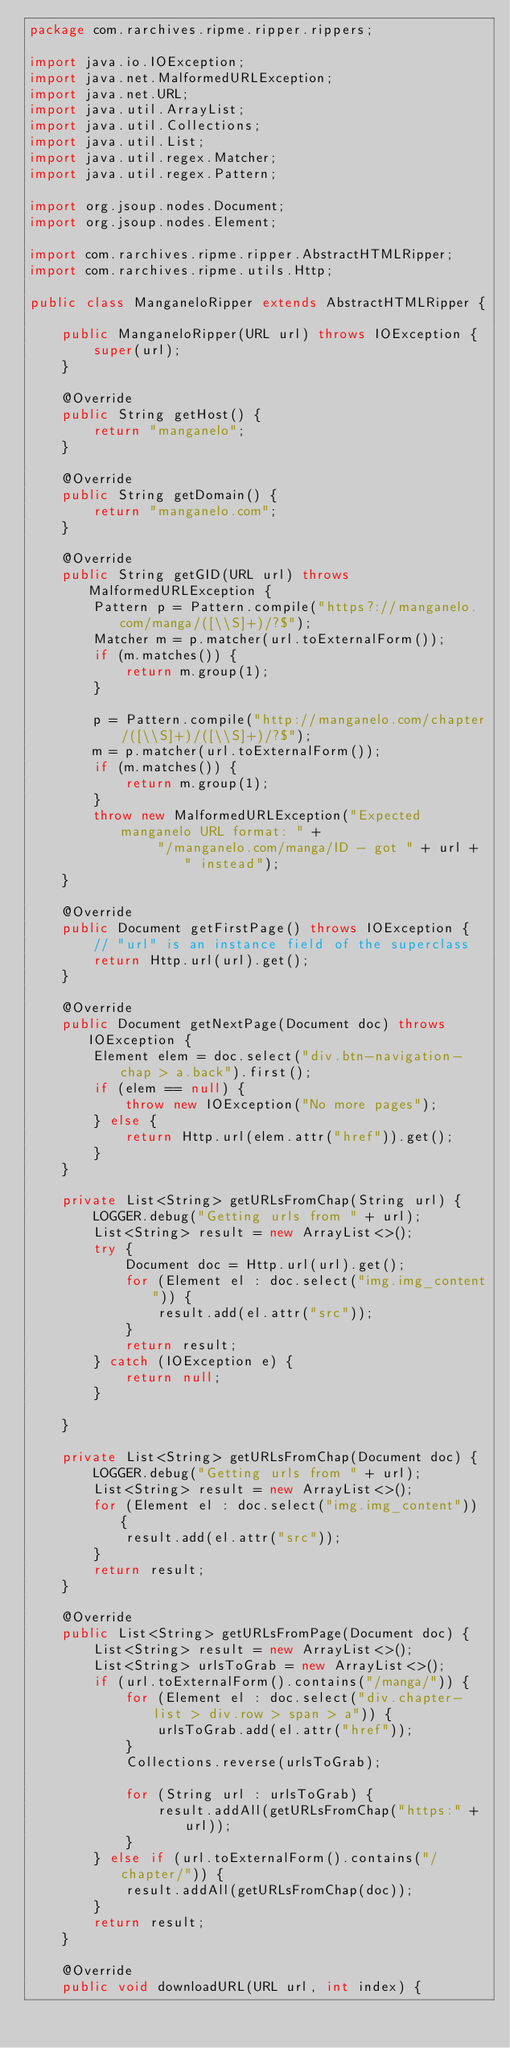Convert code to text. <code><loc_0><loc_0><loc_500><loc_500><_Java_>package com.rarchives.ripme.ripper.rippers;

import java.io.IOException;
import java.net.MalformedURLException;
import java.net.URL;
import java.util.ArrayList;
import java.util.Collections;
import java.util.List;
import java.util.regex.Matcher;
import java.util.regex.Pattern;

import org.jsoup.nodes.Document;
import org.jsoup.nodes.Element;

import com.rarchives.ripme.ripper.AbstractHTMLRipper;
import com.rarchives.ripme.utils.Http;

public class ManganeloRipper extends AbstractHTMLRipper {

    public ManganeloRipper(URL url) throws IOException {
        super(url);
    }

    @Override
    public String getHost() {
        return "manganelo";
    }

    @Override
    public String getDomain() {
        return "manganelo.com";
    }

    @Override
    public String getGID(URL url) throws MalformedURLException {
        Pattern p = Pattern.compile("https?://manganelo.com/manga/([\\S]+)/?$");
        Matcher m = p.matcher(url.toExternalForm());
        if (m.matches()) {
            return m.group(1);
        }

        p = Pattern.compile("http://manganelo.com/chapter/([\\S]+)/([\\S]+)/?$");
        m = p.matcher(url.toExternalForm());
        if (m.matches()) {
            return m.group(1);
        }
        throw new MalformedURLException("Expected manganelo URL format: " +
                "/manganelo.com/manga/ID - got " + url + " instead");
    }

    @Override
    public Document getFirstPage() throws IOException {
        // "url" is an instance field of the superclass
        return Http.url(url).get();
    }

    @Override
    public Document getNextPage(Document doc) throws IOException {
        Element elem = doc.select("div.btn-navigation-chap > a.back").first();
        if (elem == null) {
            throw new IOException("No more pages");
        } else {
            return Http.url(elem.attr("href")).get();
        }
    }

    private List<String> getURLsFromChap(String url) {
        LOGGER.debug("Getting urls from " + url);
        List<String> result = new ArrayList<>();
        try {
            Document doc = Http.url(url).get();
            for (Element el : doc.select("img.img_content")) {
                result.add(el.attr("src"));
            }
            return result;
        } catch (IOException e) {
            return null;
        }

    }

    private List<String> getURLsFromChap(Document doc) {
        LOGGER.debug("Getting urls from " + url);
        List<String> result = new ArrayList<>();
        for (Element el : doc.select("img.img_content")) {
            result.add(el.attr("src"));
        }
        return result;
    }

    @Override
    public List<String> getURLsFromPage(Document doc) {
        List<String> result = new ArrayList<>();
        List<String> urlsToGrab = new ArrayList<>();
        if (url.toExternalForm().contains("/manga/")) {
            for (Element el : doc.select("div.chapter-list > div.row > span > a")) {
                urlsToGrab.add(el.attr("href"));
            }
            Collections.reverse(urlsToGrab);

            for (String url : urlsToGrab) {
                result.addAll(getURLsFromChap("https:" + url));
            }
        } else if (url.toExternalForm().contains("/chapter/")) {
            result.addAll(getURLsFromChap(doc));
        }
        return result;
    }

    @Override
    public void downloadURL(URL url, int index) {</code> 